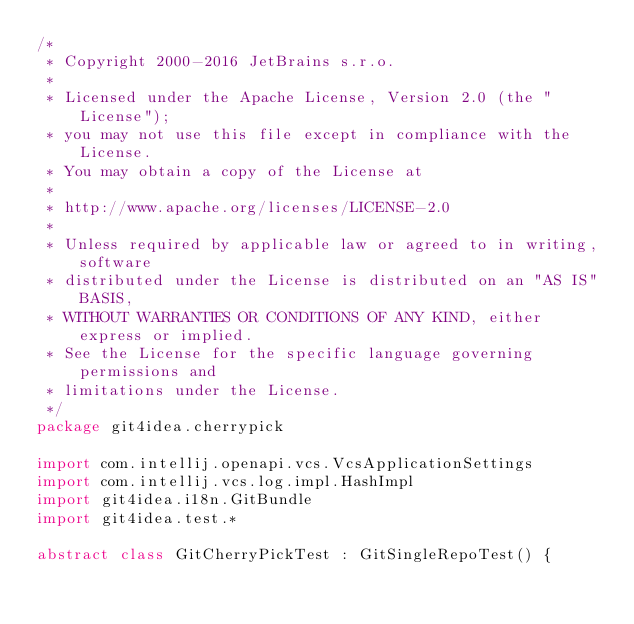<code> <loc_0><loc_0><loc_500><loc_500><_Kotlin_>/*
 * Copyright 2000-2016 JetBrains s.r.o.
 *
 * Licensed under the Apache License, Version 2.0 (the "License");
 * you may not use this file except in compliance with the License.
 * You may obtain a copy of the License at
 *
 * http://www.apache.org/licenses/LICENSE-2.0
 *
 * Unless required by applicable law or agreed to in writing, software
 * distributed under the License is distributed on an "AS IS" BASIS,
 * WITHOUT WARRANTIES OR CONDITIONS OF ANY KIND, either express or implied.
 * See the License for the specific language governing permissions and
 * limitations under the License.
 */
package git4idea.cherrypick

import com.intellij.openapi.vcs.VcsApplicationSettings
import com.intellij.vcs.log.impl.HashImpl
import git4idea.i18n.GitBundle
import git4idea.test.*

abstract class GitCherryPickTest : GitSingleRepoTest() {</code> 